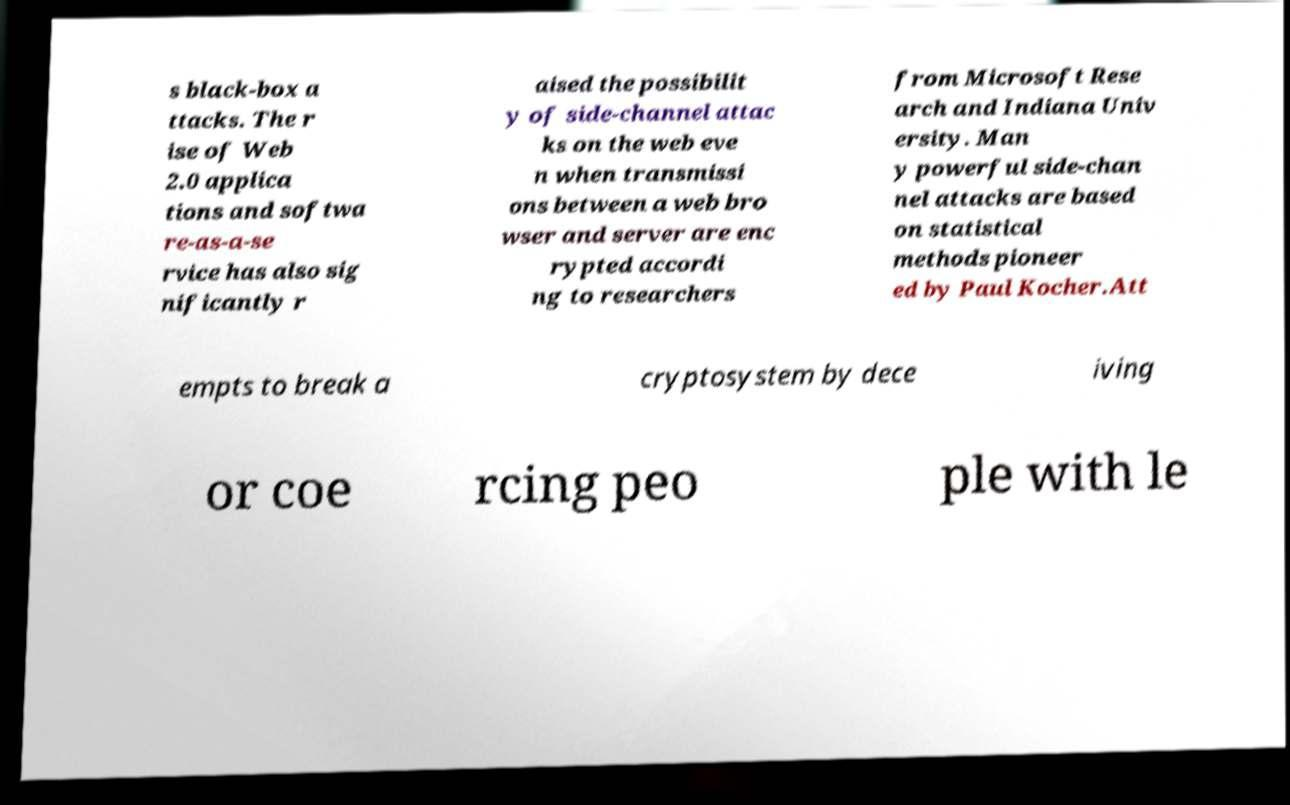Please read and relay the text visible in this image. What does it say? s black-box a ttacks. The r ise of Web 2.0 applica tions and softwa re-as-a-se rvice has also sig nificantly r aised the possibilit y of side-channel attac ks on the web eve n when transmissi ons between a web bro wser and server are enc rypted accordi ng to researchers from Microsoft Rese arch and Indiana Univ ersity. Man y powerful side-chan nel attacks are based on statistical methods pioneer ed by Paul Kocher.Att empts to break a cryptosystem by dece iving or coe rcing peo ple with le 